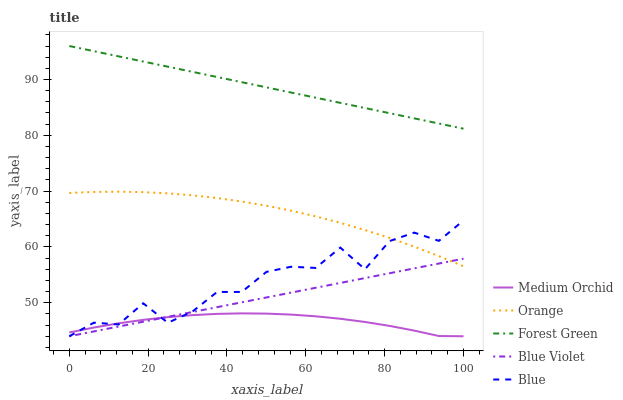Does Medium Orchid have the minimum area under the curve?
Answer yes or no. Yes. Does Forest Green have the maximum area under the curve?
Answer yes or no. Yes. Does Blue have the minimum area under the curve?
Answer yes or no. No. Does Blue have the maximum area under the curve?
Answer yes or no. No. Is Blue Violet the smoothest?
Answer yes or no. Yes. Is Blue the roughest?
Answer yes or no. Yes. Is Forest Green the smoothest?
Answer yes or no. No. Is Forest Green the roughest?
Answer yes or no. No. Does Forest Green have the lowest value?
Answer yes or no. No. Does Forest Green have the highest value?
Answer yes or no. Yes. Does Blue have the highest value?
Answer yes or no. No. Is Medium Orchid less than Orange?
Answer yes or no. Yes. Is Forest Green greater than Blue?
Answer yes or no. Yes. Does Medium Orchid intersect Orange?
Answer yes or no. No. 